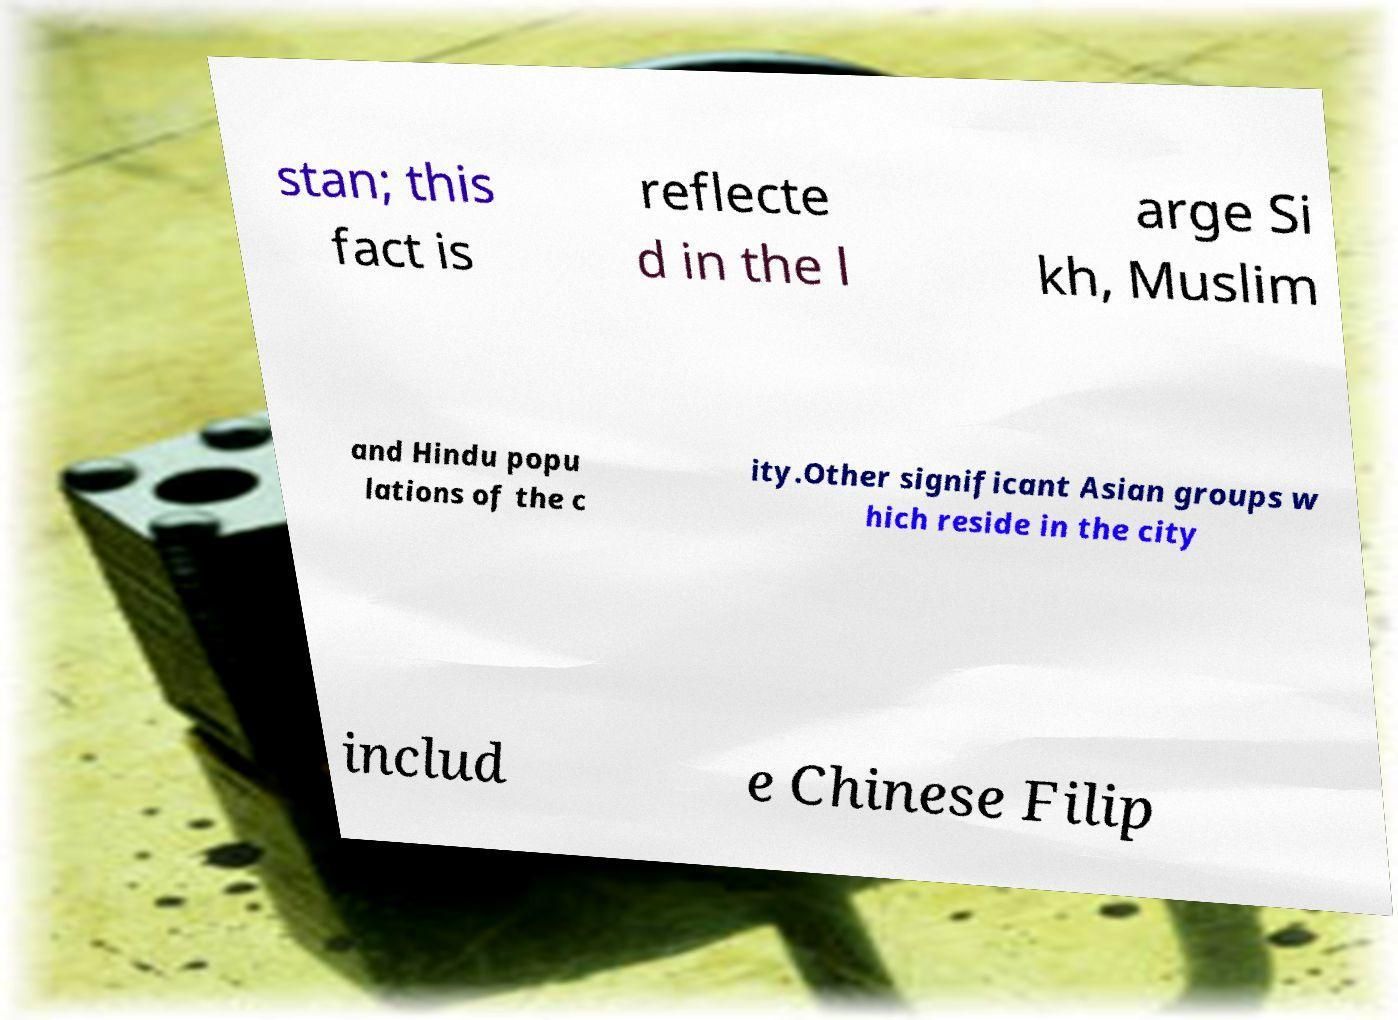Please read and relay the text visible in this image. What does it say? stan; this fact is reflecte d in the l arge Si kh, Muslim and Hindu popu lations of the c ity.Other significant Asian groups w hich reside in the city includ e Chinese Filip 